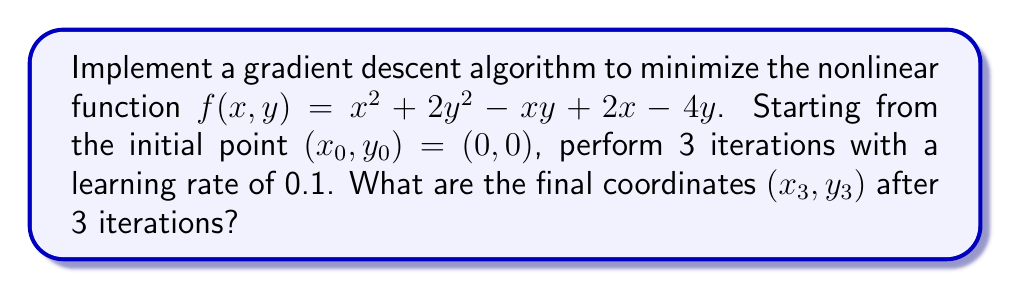Give your solution to this math problem. Let's approach this step-by-step:

1) First, we need to calculate the gradient of the function:
   $$\nabla f(x, y) = \begin{bmatrix}
   \frac{\partial f}{\partial x} \\
   \frac{\partial f}{\partial y}
   \end{bmatrix} = \begin{bmatrix}
   2x - y + 2 \\
   4y - x - 4
   \end{bmatrix}$$

2) The update rule for gradient descent is:
   $$(x_{n+1}, y_{n+1}) = (x_n, y_n) - \alpha \nabla f(x_n, y_n)$$
   where $\alpha = 0.1$ is the learning rate.

3) Let's perform the iterations:

   Iteration 1:
   $$\nabla f(0, 0) = \begin{bmatrix} 2 \\ -4 \end{bmatrix}$$
   $$(x_1, y_1) = (0, 0) - 0.1 \begin{bmatrix} 2 \\ -4 \end{bmatrix} = (-0.2, 0.4)$$

   Iteration 2:
   $$\nabla f(-0.2, 0.4) = \begin{bmatrix} -0.4 - 0.4 + 2 \\ 1.6 + 0.2 - 4 \end{bmatrix} = \begin{bmatrix} 1.2 \\ -2.2 \end{bmatrix}$$
   $$(x_2, y_2) = (-0.2, 0.4) - 0.1 \begin{bmatrix} 1.2 \\ -2.2 \end{bmatrix} = (-0.32, 0.62)$$

   Iteration 3:
   $$\nabla f(-0.32, 0.62) = \begin{bmatrix} -0.64 - 0.62 + 2 \\ 2.48 + 0.32 - 4 \end{bmatrix} = \begin{bmatrix} 0.74 \\ -1.2 \end{bmatrix}$$
   $$(x_3, y_3) = (-0.32, 0.62) - 0.1 \begin{bmatrix} 0.74 \\ -1.2 \end{bmatrix} = (-0.394, 0.74)$$

4) Therefore, after 3 iterations, the final coordinates are $(-0.394, 0.74)$.
Answer: $(-0.394, 0.74)$ 